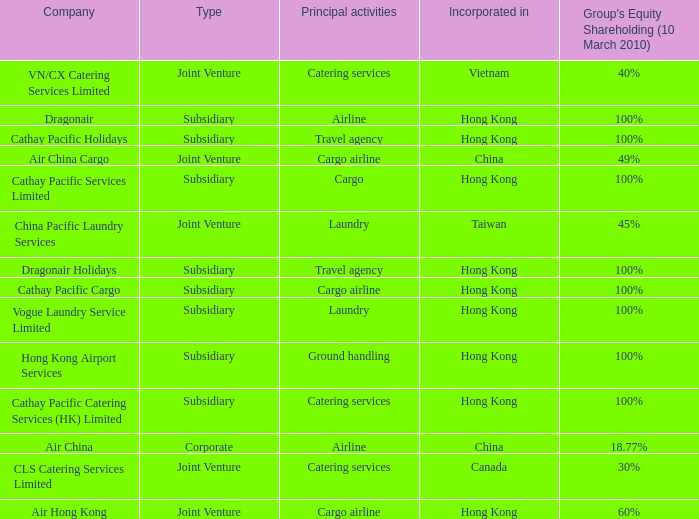What is the type for the Cathay Pacific Holidays company, an incorporation of Hong Kong and listed activities as Travel Agency? Subsidiary. 